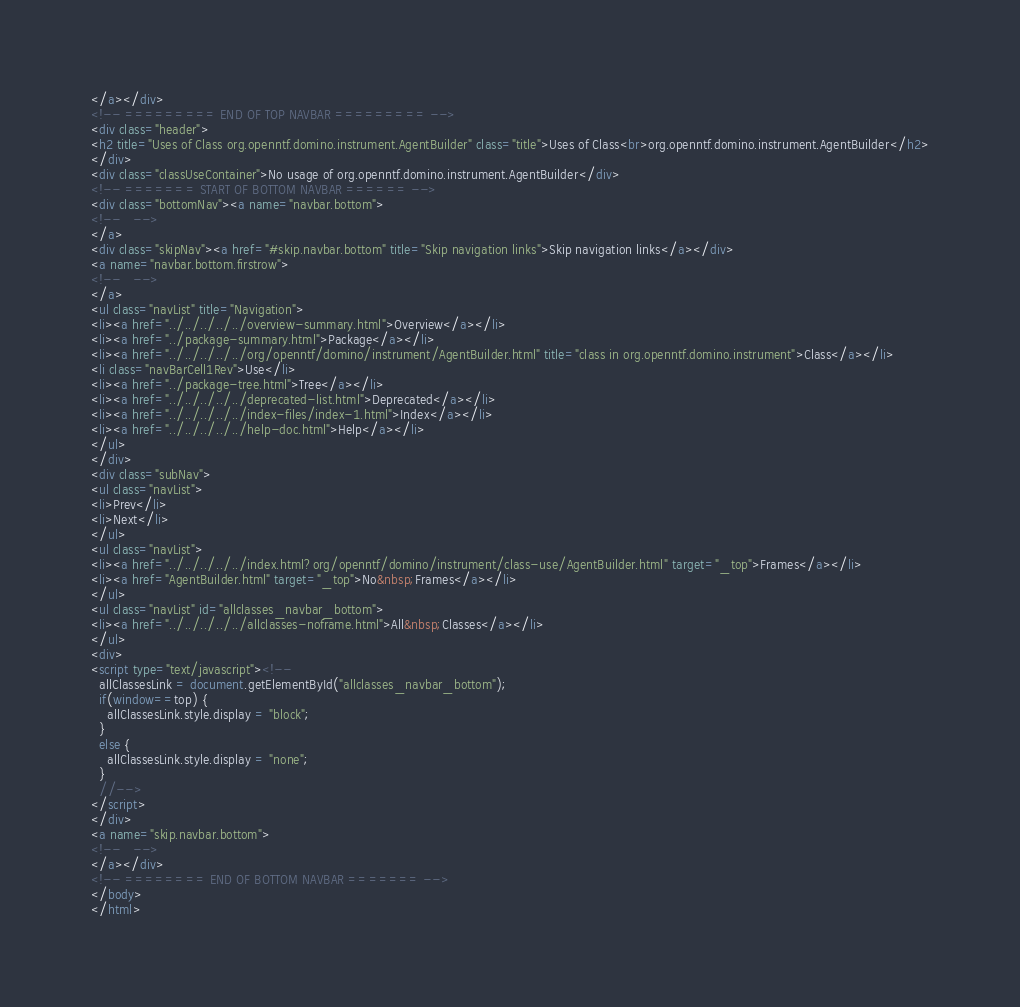<code> <loc_0><loc_0><loc_500><loc_500><_HTML_></a></div>
<!-- ========= END OF TOP NAVBAR ========= -->
<div class="header">
<h2 title="Uses of Class org.openntf.domino.instrument.AgentBuilder" class="title">Uses of Class<br>org.openntf.domino.instrument.AgentBuilder</h2>
</div>
<div class="classUseContainer">No usage of org.openntf.domino.instrument.AgentBuilder</div>
<!-- ======= START OF BOTTOM NAVBAR ====== -->
<div class="bottomNav"><a name="navbar.bottom">
<!--   -->
</a>
<div class="skipNav"><a href="#skip.navbar.bottom" title="Skip navigation links">Skip navigation links</a></div>
<a name="navbar.bottom.firstrow">
<!--   -->
</a>
<ul class="navList" title="Navigation">
<li><a href="../../../../../overview-summary.html">Overview</a></li>
<li><a href="../package-summary.html">Package</a></li>
<li><a href="../../../../../org/openntf/domino/instrument/AgentBuilder.html" title="class in org.openntf.domino.instrument">Class</a></li>
<li class="navBarCell1Rev">Use</li>
<li><a href="../package-tree.html">Tree</a></li>
<li><a href="../../../../../deprecated-list.html">Deprecated</a></li>
<li><a href="../../../../../index-files/index-1.html">Index</a></li>
<li><a href="../../../../../help-doc.html">Help</a></li>
</ul>
</div>
<div class="subNav">
<ul class="navList">
<li>Prev</li>
<li>Next</li>
</ul>
<ul class="navList">
<li><a href="../../../../../index.html?org/openntf/domino/instrument/class-use/AgentBuilder.html" target="_top">Frames</a></li>
<li><a href="AgentBuilder.html" target="_top">No&nbsp;Frames</a></li>
</ul>
<ul class="navList" id="allclasses_navbar_bottom">
<li><a href="../../../../../allclasses-noframe.html">All&nbsp;Classes</a></li>
</ul>
<div>
<script type="text/javascript"><!--
  allClassesLink = document.getElementById("allclasses_navbar_bottom");
  if(window==top) {
    allClassesLink.style.display = "block";
  }
  else {
    allClassesLink.style.display = "none";
  }
  //-->
</script>
</div>
<a name="skip.navbar.bottom">
<!--   -->
</a></div>
<!-- ======== END OF BOTTOM NAVBAR ======= -->
</body>
</html>
</code> 